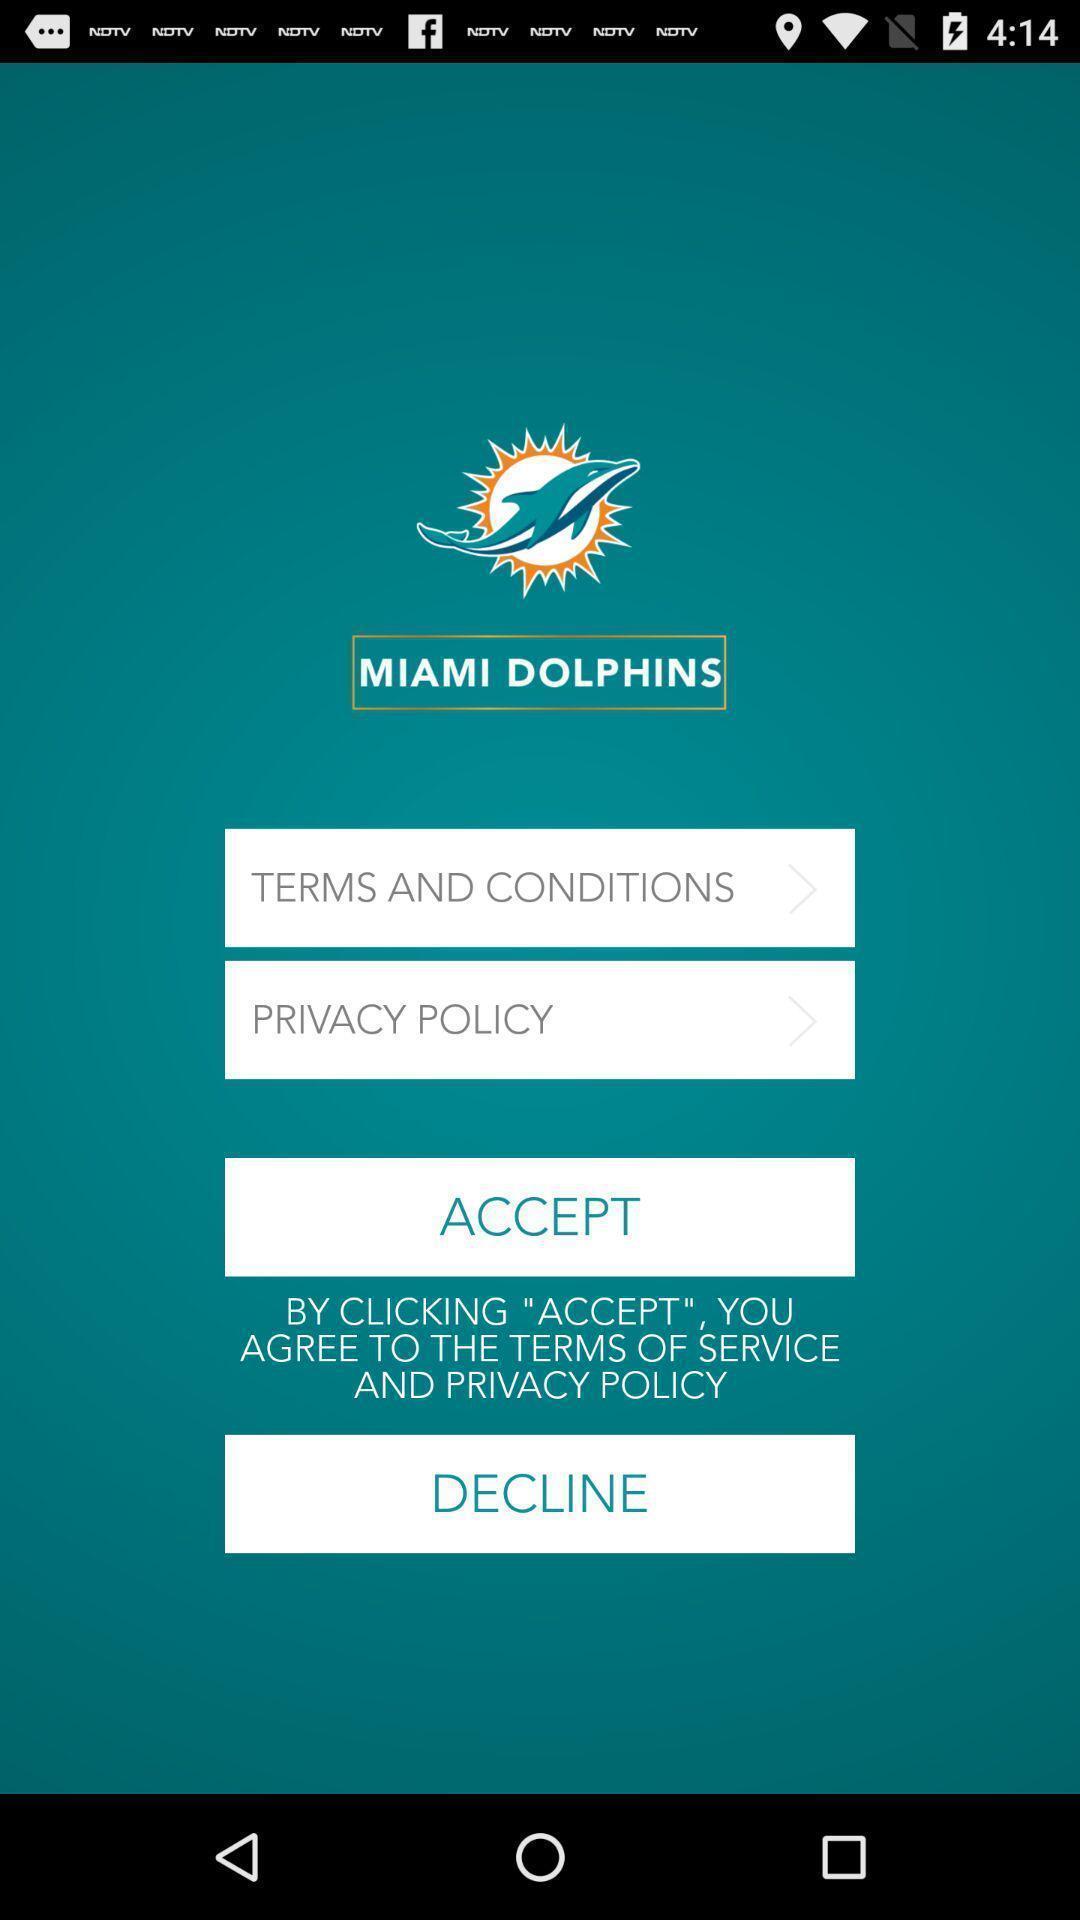Give me a narrative description of this picture. Welcome page displaying terms and conditions. 